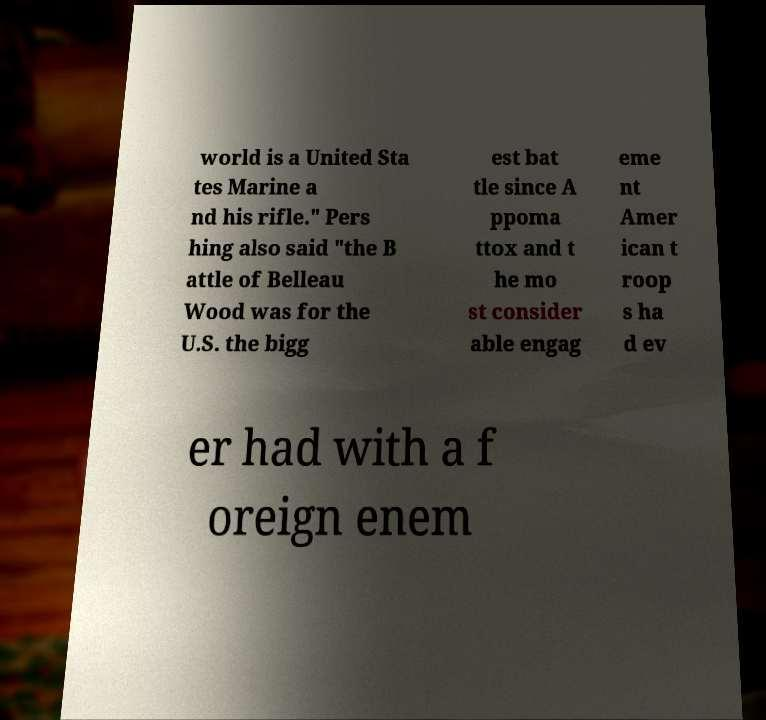Can you read and provide the text displayed in the image?This photo seems to have some interesting text. Can you extract and type it out for me? world is a United Sta tes Marine a nd his rifle." Pers hing also said "the B attle of Belleau Wood was for the U.S. the bigg est bat tle since A ppoma ttox and t he mo st consider able engag eme nt Amer ican t roop s ha d ev er had with a f oreign enem 